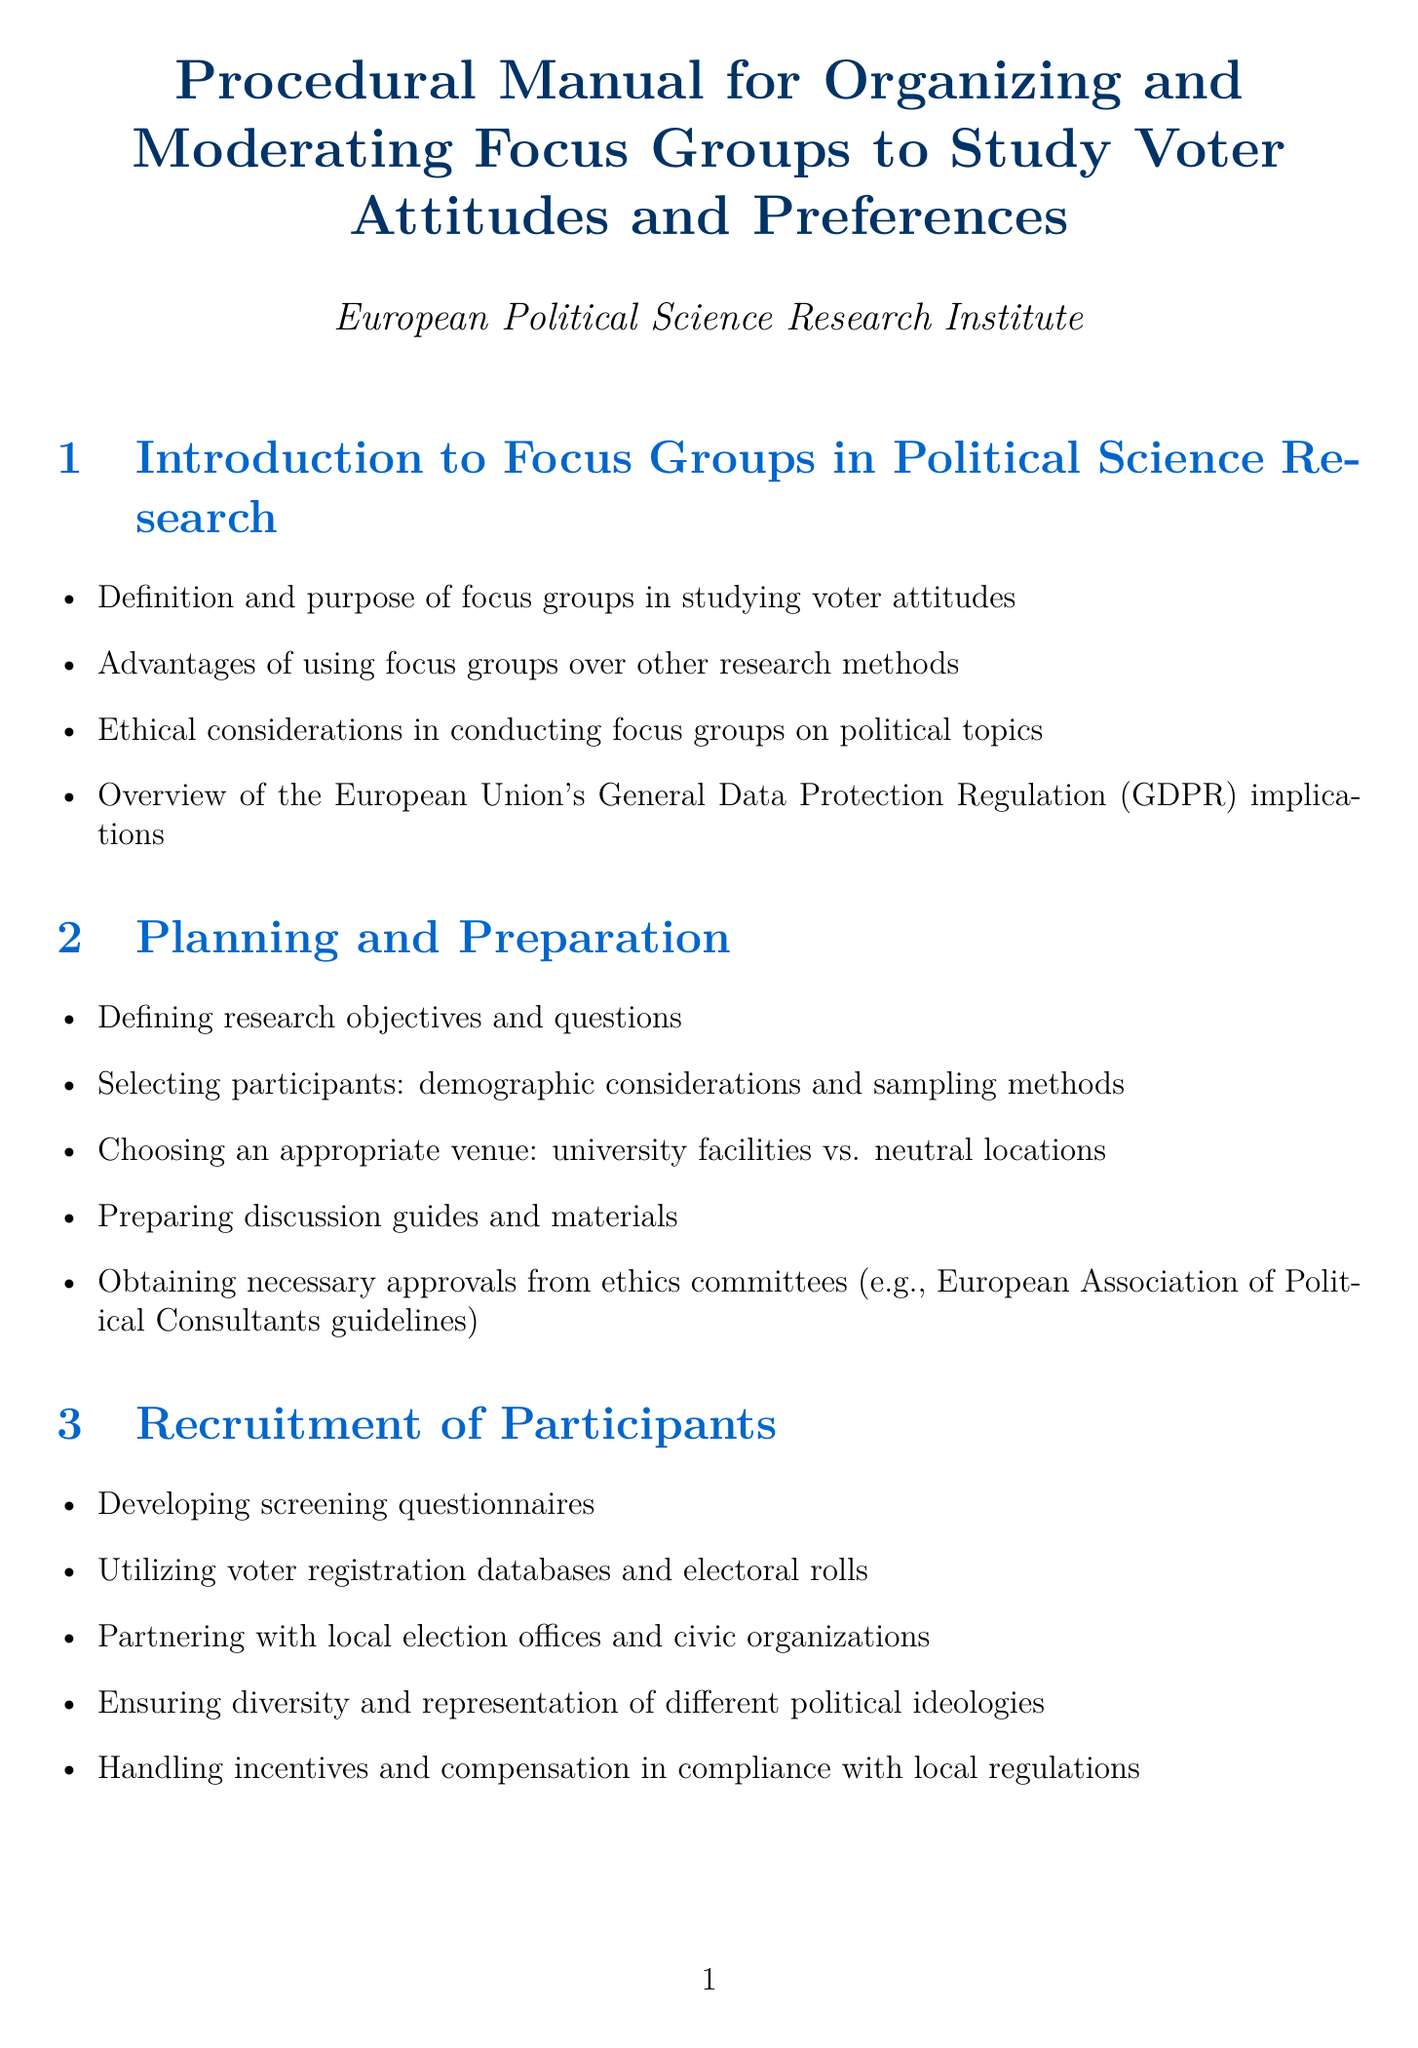what is the purpose of focus groups in political science research? The purpose of focus groups in political science research is to study voter attitudes.
Answer: study voter attitudes what are two advantages of using focus groups over other research methods? The document mentions advantages like gaining in-depth insights and understanding group dynamics.
Answer: in-depth insights, understanding group dynamics what should be obtained from ethics committees before conducting focus groups? Necessary approvals from ethics committees should be obtained before conducting focus groups.
Answer: necessary approvals which software is recommended for coding and analyzing qualitative data? The document recommends NVivo or ATLAS.ti for coding and analyzing qualitative data.
Answer: NVivo, ATLAS.ti what is one ethical consideration mentioned in the managing of focus groups? Ensuring data protection is one of the ethical considerations mentioned.
Answer: ensuring data protection how should participant consent forms comply with what regulations? Participant consent forms should comply with EU research ethics regulations.
Answer: EU research ethics what is one technique for maintaining neutrality in focus group moderation? One technique for maintaining neutrality is avoiding bias.
Answer: avoiding bias what type of activities are recommended to encourage participation in political discussions? Ice-breaker activities tailored to political discussions are recommended.
Answer: ice-breaker activities how can focus group methods be adapted for different European political systems? Focus group methods can be adapted by addressing language barriers and cultural differences associated with different systems.
Answer: addressing language barriers and cultural differences 